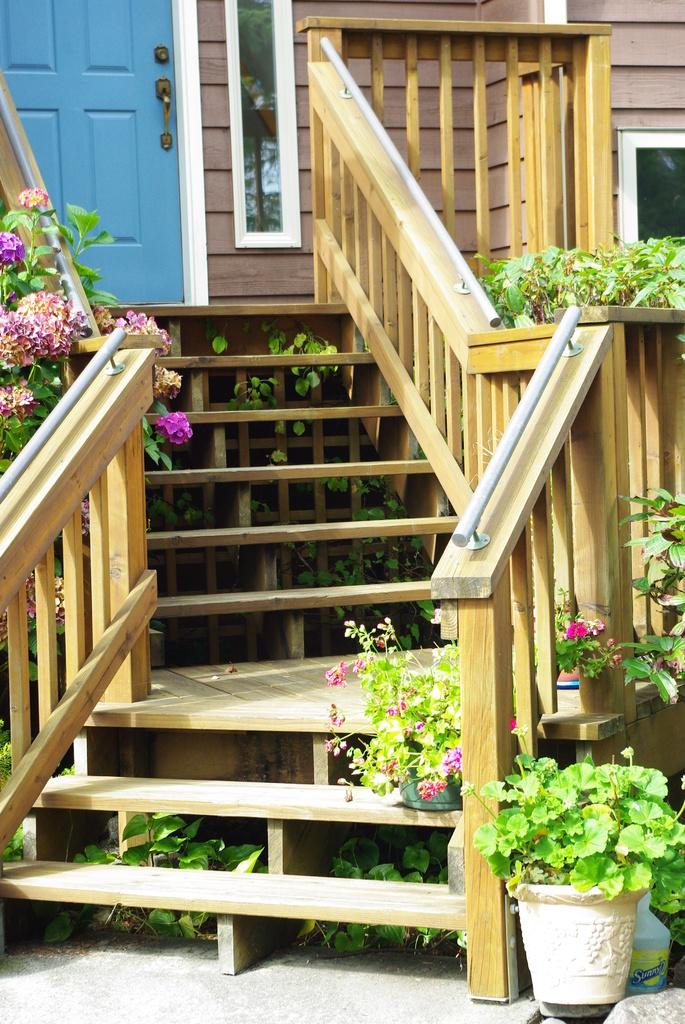What type of architectural feature can be seen in the image? There are steps in the image. What is the purpose of the steps? The steps might be used for accessing a higher level or as a decorative element. What else can be seen in the image? There is a door and plants with flowers in the image. What might the door be used for? The door might be used for entering or exiting a building or room. Can you describe the plants with flowers in the image? The plants with flowers are likely decorative and add color and life to the scene. How many sheep are visible in the image? There are no sheep present in the image. What is the duration of the point in the image? There is no point present in the image, so it is not possible to determine its duration. 